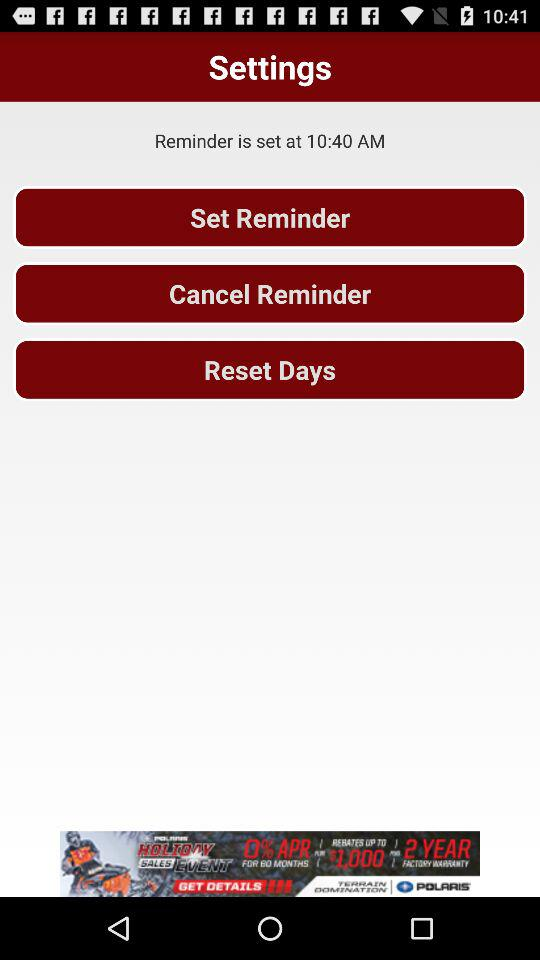For which days is the reminder set?
When the provided information is insufficient, respond with <no answer>. <no answer> 